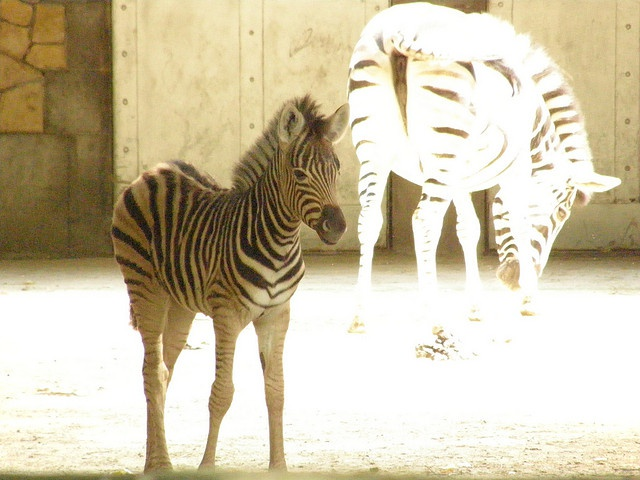Describe the objects in this image and their specific colors. I can see zebra in olive, white, khaki, and tan tones and zebra in olive, tan, and black tones in this image. 